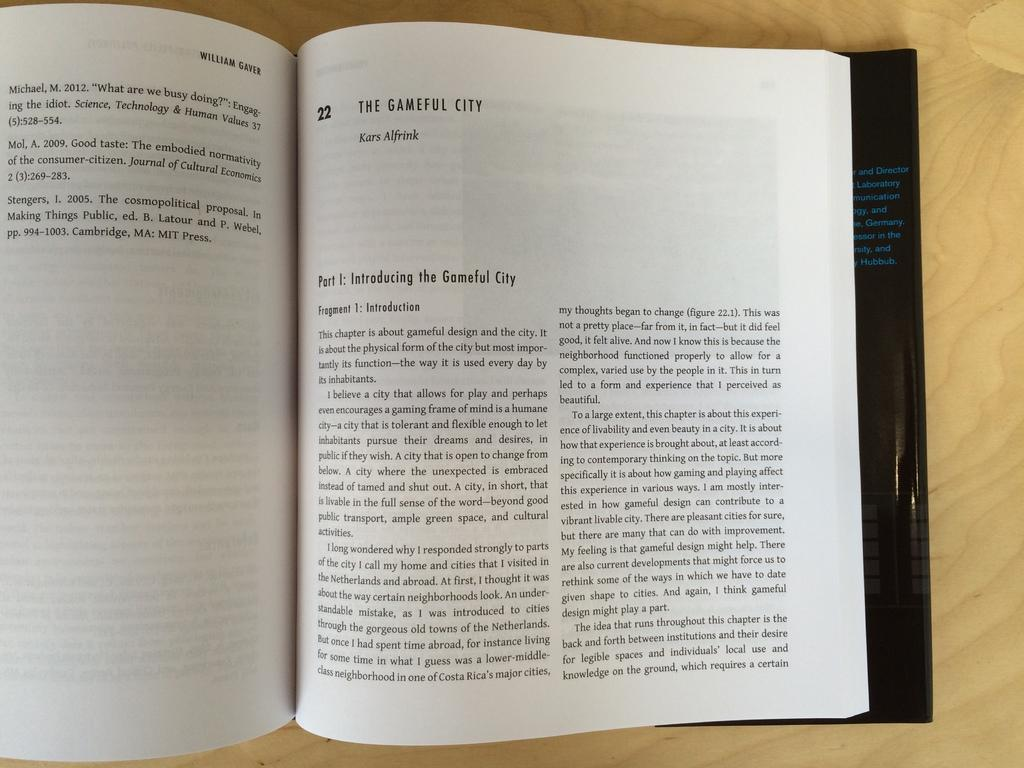<image>
Write a terse but informative summary of the picture. A book is opened to The Gameful City by Kars Alfrink. 